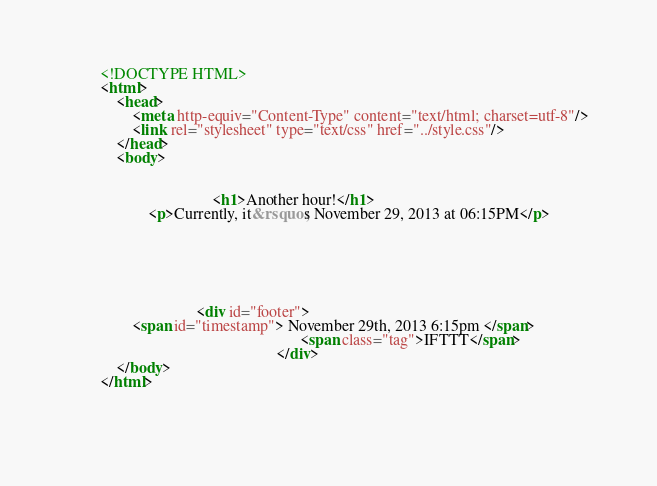Convert code to text. <code><loc_0><loc_0><loc_500><loc_500><_HTML_>        <!DOCTYPE HTML>
        <html>
            <head>
                <meta http-equiv="Content-Type" content="text/html; charset=utf-8"/>
                <link rel="stylesheet" type="text/css" href="../style.css"/>
            </head>
            <body>
                
                
                                    <h1>Another hour!</h1>
                    <p>Currently, it&rsquo;s November 29, 2013 at 06:15PM</p>
                
                
                
                
                
                
                                <div id="footer">
                <span id="timestamp"> November 29th, 2013 6:15pm </span>
                                                          <span class="tag">IFTTT</span>
                                                    </div>
            </body>
        </html>

        </code> 